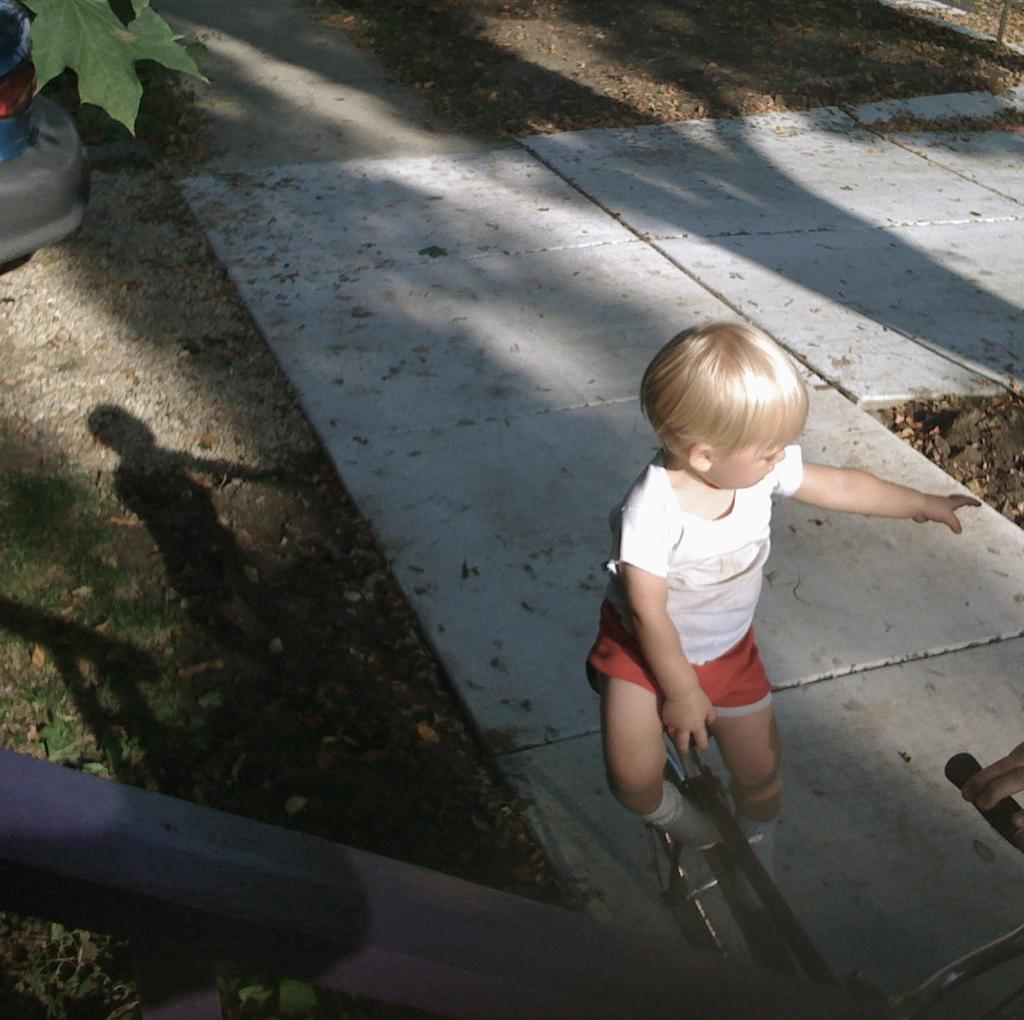Where is the kid located in the image? The kid is on the right side of the image. What is the kid doing in the image? The kid is sitting on a bicycle. What can be seen at the bottom of the image? There is a fence at the bottom of the image. What is visible in the background of the image? There is a walkway in the background of the image. What type of eggnog is the kid drinking in the image? There is no eggnog present in the image; the kid is sitting on a bicycle. Can you see any ants crawling on the fence in the image? There are no ants visible in the image; only the fence can be seen at the bottom. 